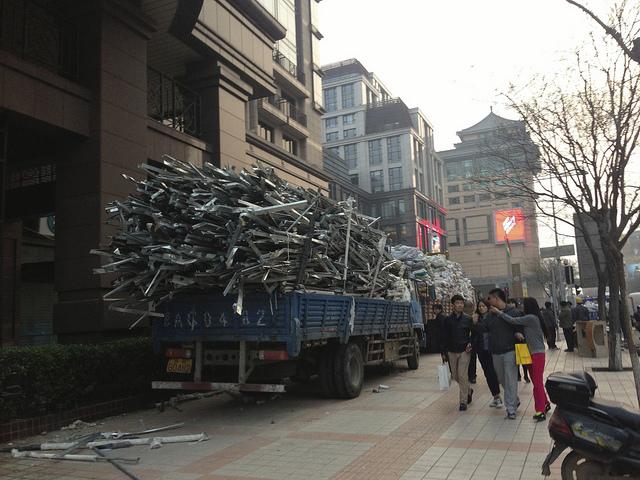Is there one pair of pants that standout?
Answer briefly. Yes. Are there leaves on the trees?
Keep it brief. No. What street is this taking place?
Concise answer only. Unknown. Is this indoors?
Answer briefly. No. 